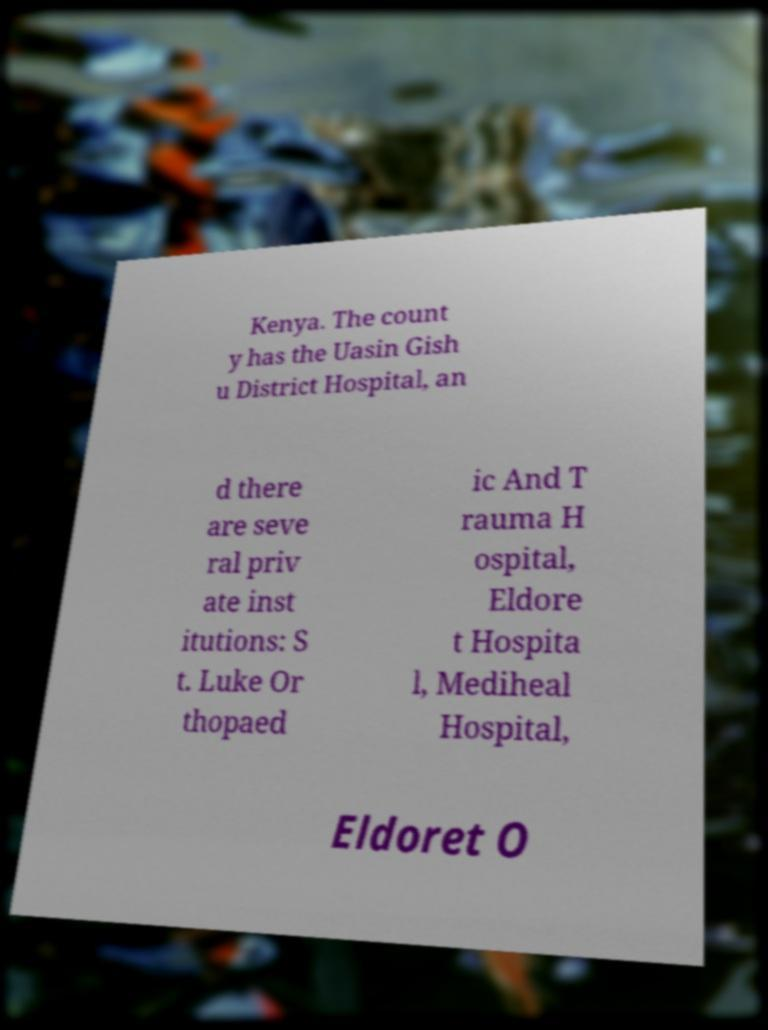There's text embedded in this image that I need extracted. Can you transcribe it verbatim? Kenya. The count y has the Uasin Gish u District Hospital, an d there are seve ral priv ate inst itutions: S t. Luke Or thopaed ic And T rauma H ospital, Eldore t Hospita l, Mediheal Hospital, Eldoret O 